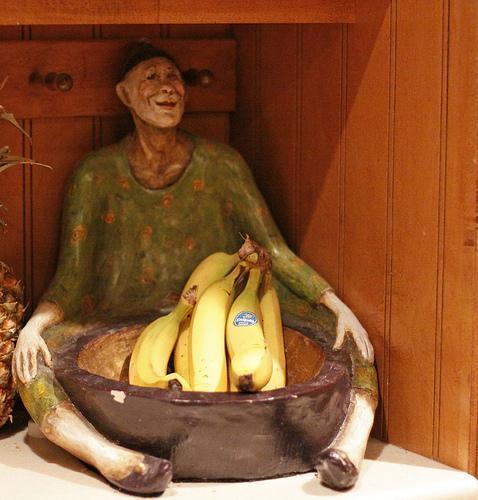How many people are wearing orange jackets?
Give a very brief answer. 0. 